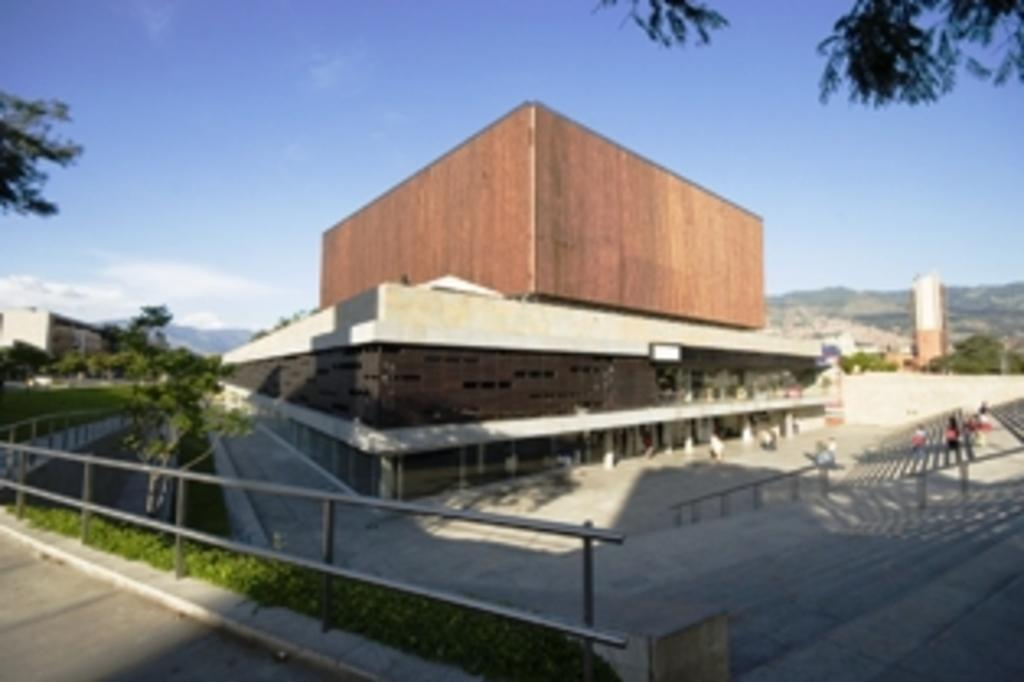What type of objects can be seen in the image? There are iron rods in the image. What living organisms are present in the image? There are plants and trees in the image. What man-made structures can be seen in the image? There are buildings in the image. What natural features are visible in the image? There are hills in the image. What part of the natural environment is visible in the background of the image? The sky is visible in the background of the image. Can you see a volcano erupting in the image? No, there is no volcano present in the image. Is there a self-portrait of the artist in the image? No, there is no self-portrait or reference to the artist in the image. 